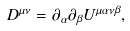<formula> <loc_0><loc_0><loc_500><loc_500>D ^ { \mu \nu } = \partial _ { \alpha } \partial _ { \beta } U ^ { \mu \alpha \nu \beta } ,</formula> 